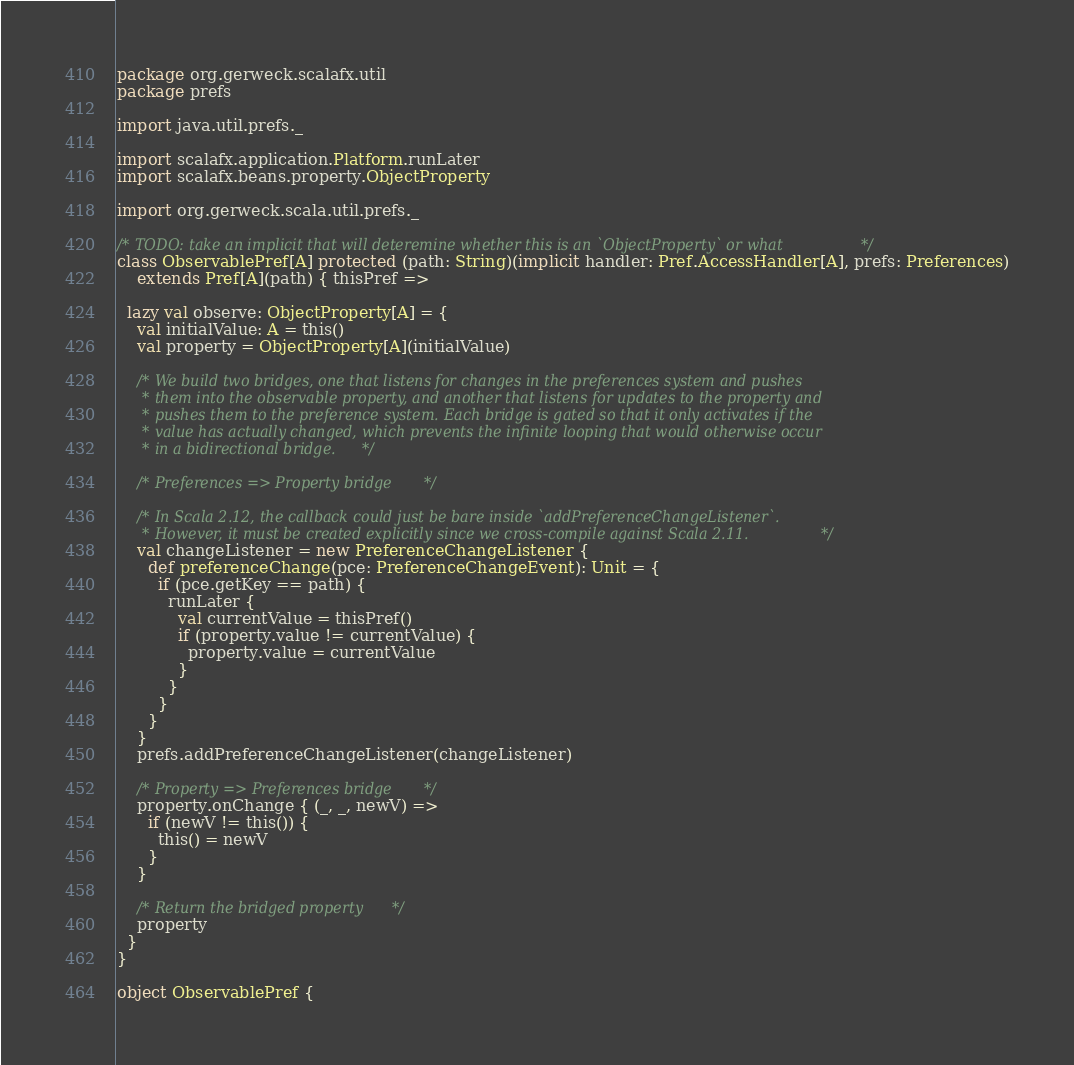<code> <loc_0><loc_0><loc_500><loc_500><_Scala_>package org.gerweck.scalafx.util
package prefs

import java.util.prefs._

import scalafx.application.Platform.runLater
import scalafx.beans.property.ObjectProperty

import org.gerweck.scala.util.prefs._

/* TODO: take an implicit that will deteremine whether this is an `ObjectProperty` or what */
class ObservablePref[A] protected (path: String)(implicit handler: Pref.AccessHandler[A], prefs: Preferences)
    extends Pref[A](path) { thisPref =>

  lazy val observe: ObjectProperty[A] = {
    val initialValue: A = this()
    val property = ObjectProperty[A](initialValue)

    /* We build two bridges, one that listens for changes in the preferences system and pushes
     * them into the observable property, and another that listens for updates to the property and
     * pushes them to the preference system. Each bridge is gated so that it only activates if the
     * value has actually changed, which prevents the infinite looping that would otherwise occur
     * in a bidirectional bridge. */

    /* Preferences => Property bridge */

    /* In Scala 2.12, the callback could just be bare inside `addPreferenceChangeListener`.
     * However, it must be created explicitly since we cross-compile against Scala 2.11. */
    val changeListener = new PreferenceChangeListener {
      def preferenceChange(pce: PreferenceChangeEvent): Unit = {
        if (pce.getKey == path) {
          runLater {
            val currentValue = thisPref()
            if (property.value != currentValue) {
              property.value = currentValue
            }
          }
        }
      }
    }
    prefs.addPreferenceChangeListener(changeListener)

    /* Property => Preferences bridge */
    property.onChange { (_, _, newV) =>
      if (newV != this()) {
        this() = newV
      }
    }

    /* Return the bridged property */
    property
  }
}

object ObservablePref {</code> 